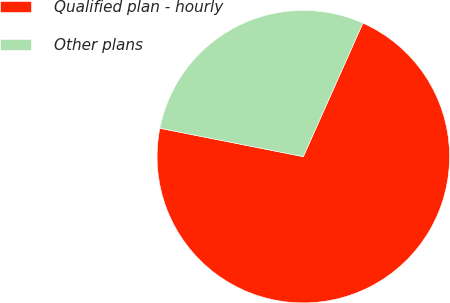Convert chart. <chart><loc_0><loc_0><loc_500><loc_500><pie_chart><fcel>Qualified plan - hourly<fcel>Other plans<nl><fcel>71.43%<fcel>28.57%<nl></chart> 